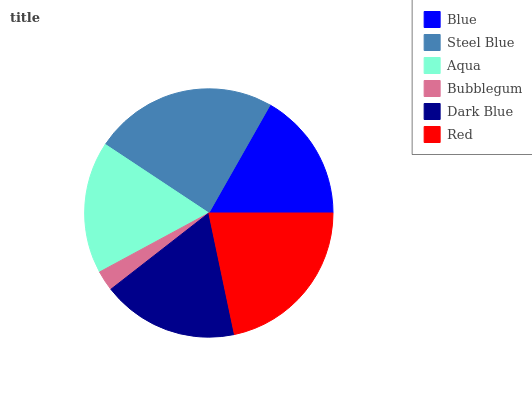Is Bubblegum the minimum?
Answer yes or no. Yes. Is Steel Blue the maximum?
Answer yes or no. Yes. Is Aqua the minimum?
Answer yes or no. No. Is Aqua the maximum?
Answer yes or no. No. Is Steel Blue greater than Aqua?
Answer yes or no. Yes. Is Aqua less than Steel Blue?
Answer yes or no. Yes. Is Aqua greater than Steel Blue?
Answer yes or no. No. Is Steel Blue less than Aqua?
Answer yes or no. No. Is Dark Blue the high median?
Answer yes or no. Yes. Is Aqua the low median?
Answer yes or no. Yes. Is Bubblegum the high median?
Answer yes or no. No. Is Red the low median?
Answer yes or no. No. 